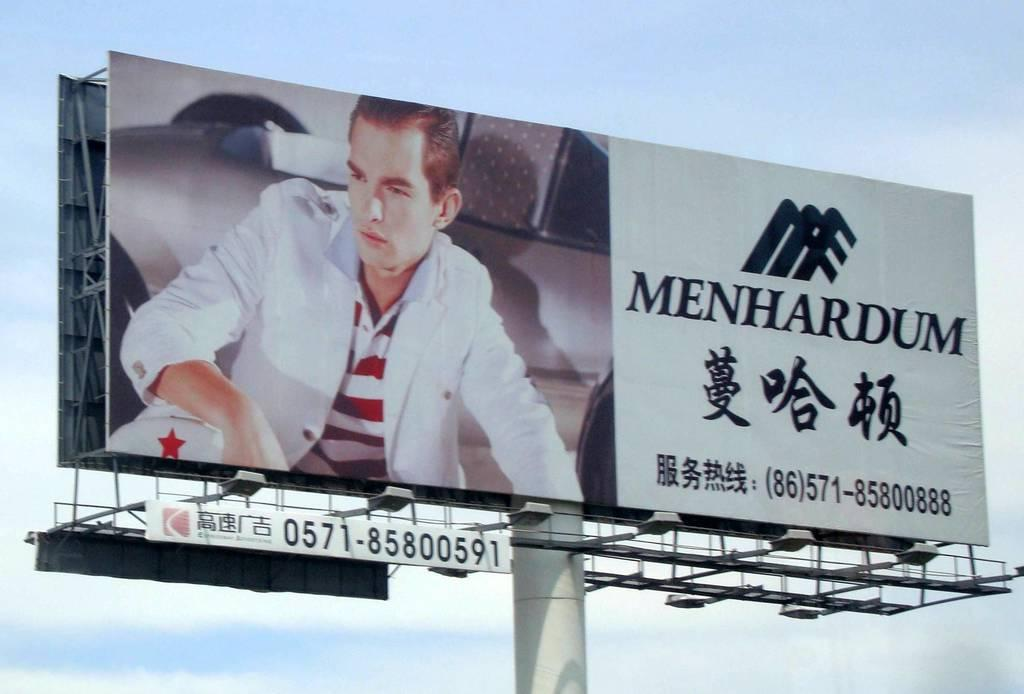<image>
Relay a brief, clear account of the picture shown. A large billboard for Menhardum shows a man wearing a white jacket. 